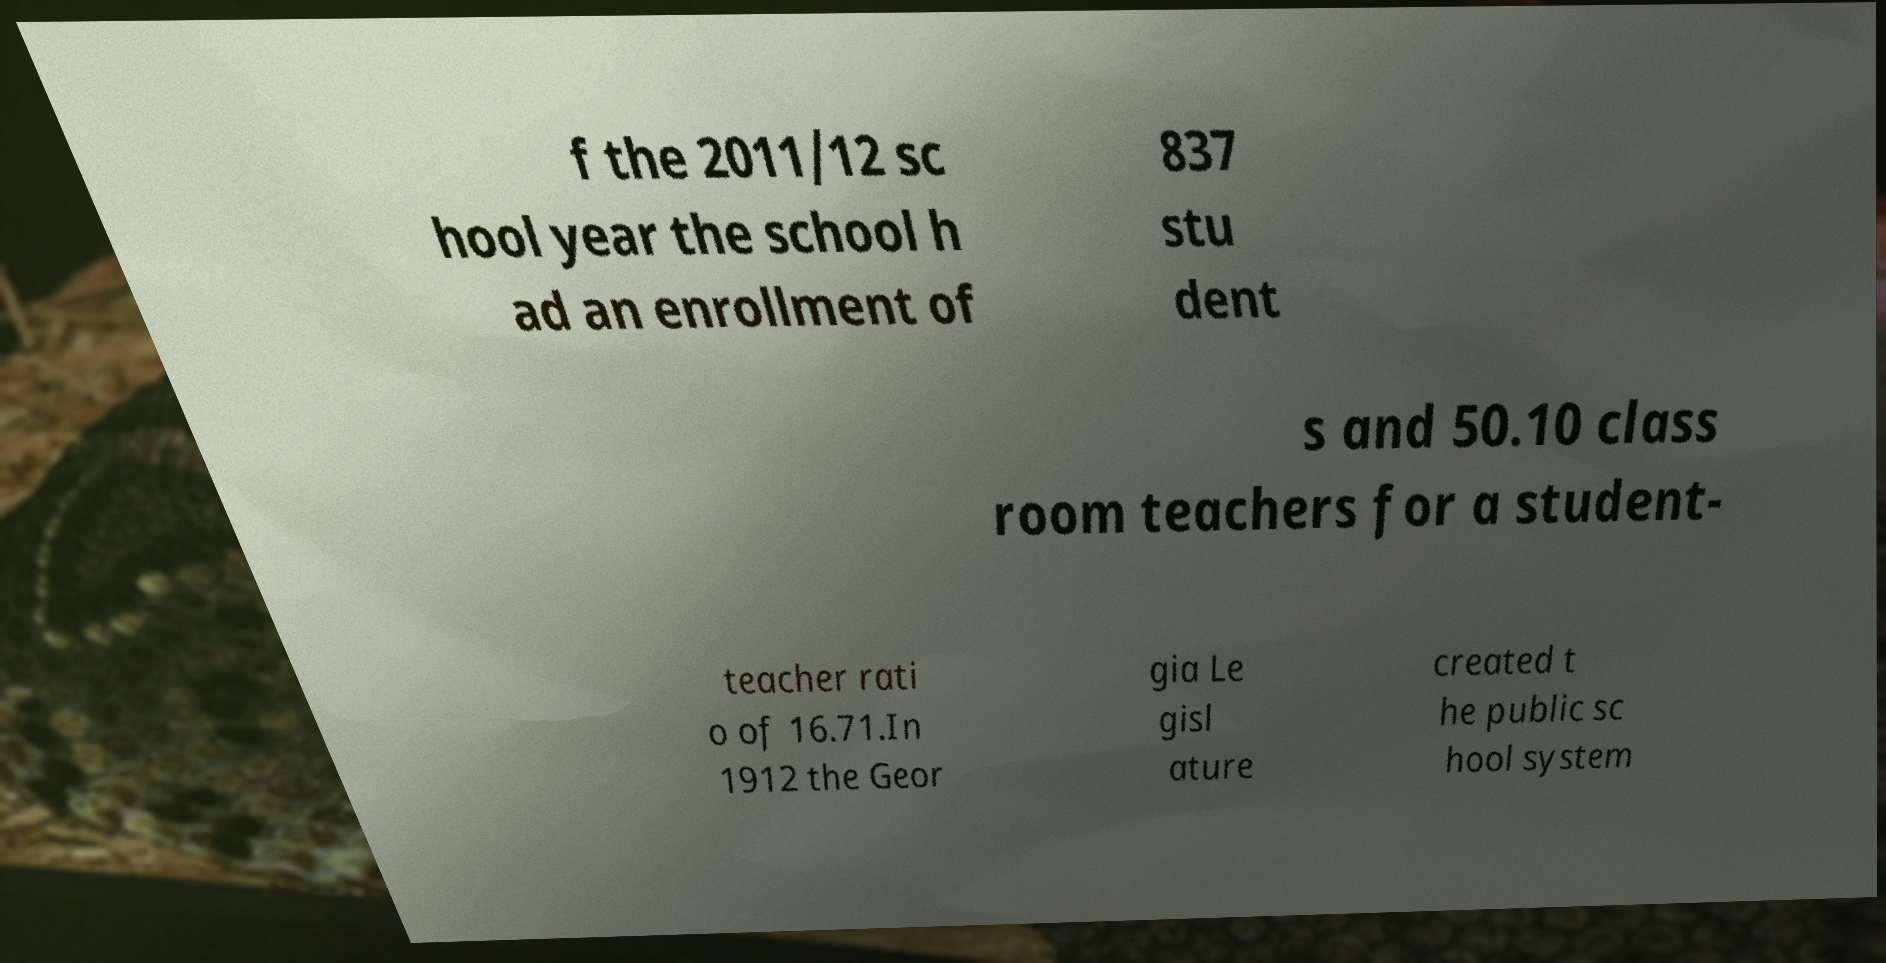I need the written content from this picture converted into text. Can you do that? f the 2011/12 sc hool year the school h ad an enrollment of 837 stu dent s and 50.10 class room teachers for a student- teacher rati o of 16.71.In 1912 the Geor gia Le gisl ature created t he public sc hool system 